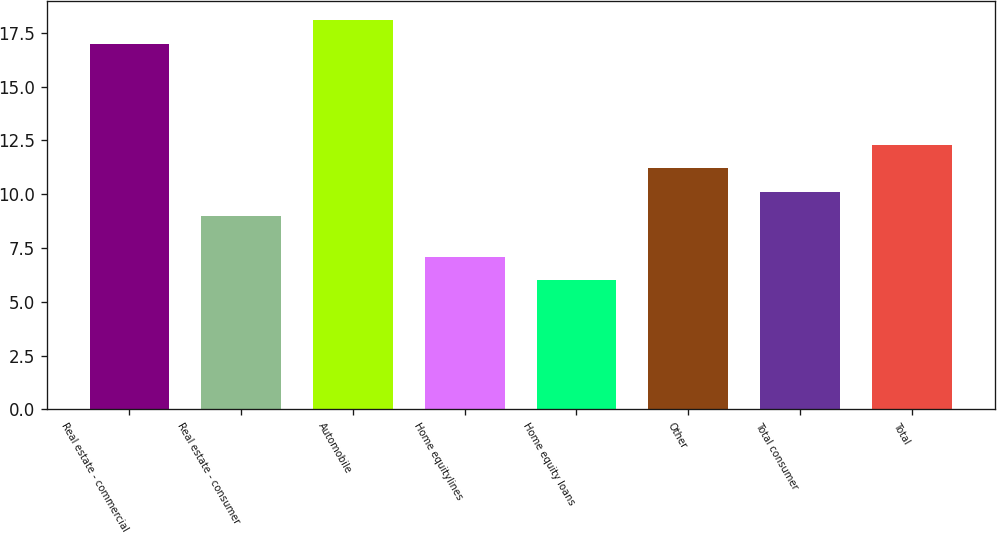Convert chart. <chart><loc_0><loc_0><loc_500><loc_500><bar_chart><fcel>Real estate - commercial<fcel>Real estate - consumer<fcel>Automobile<fcel>Home equitylines<fcel>Home equity loans<fcel>Other<fcel>Total consumer<fcel>Total<nl><fcel>17<fcel>9<fcel>18.1<fcel>7.1<fcel>6<fcel>11.2<fcel>10.1<fcel>12.3<nl></chart> 